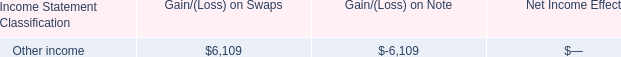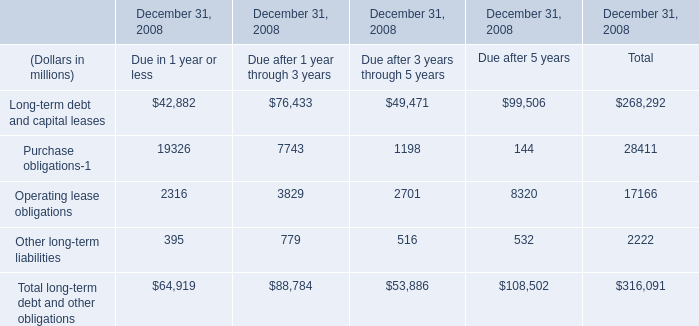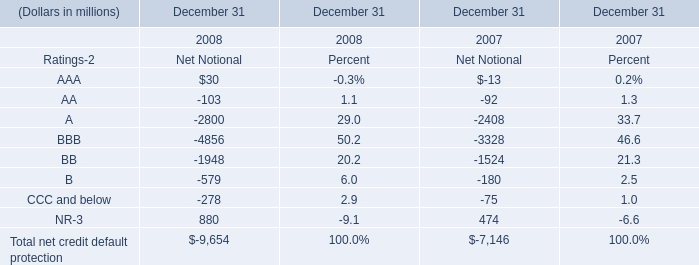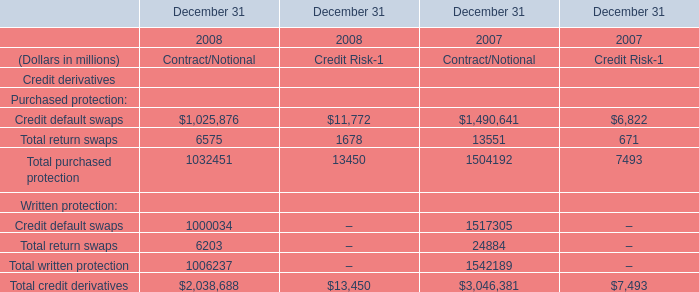What is the ratio of Credit default swaps to the total in 2008? 
Computations: (1025876 / 1032451)
Answer: 0.99363. 